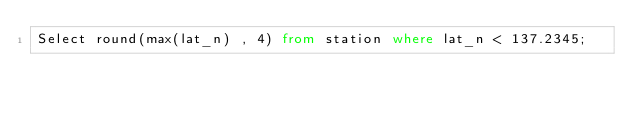Convert code to text. <code><loc_0><loc_0><loc_500><loc_500><_SQL_>Select round(max(lat_n) , 4) from station where lat_n < 137.2345;</code> 